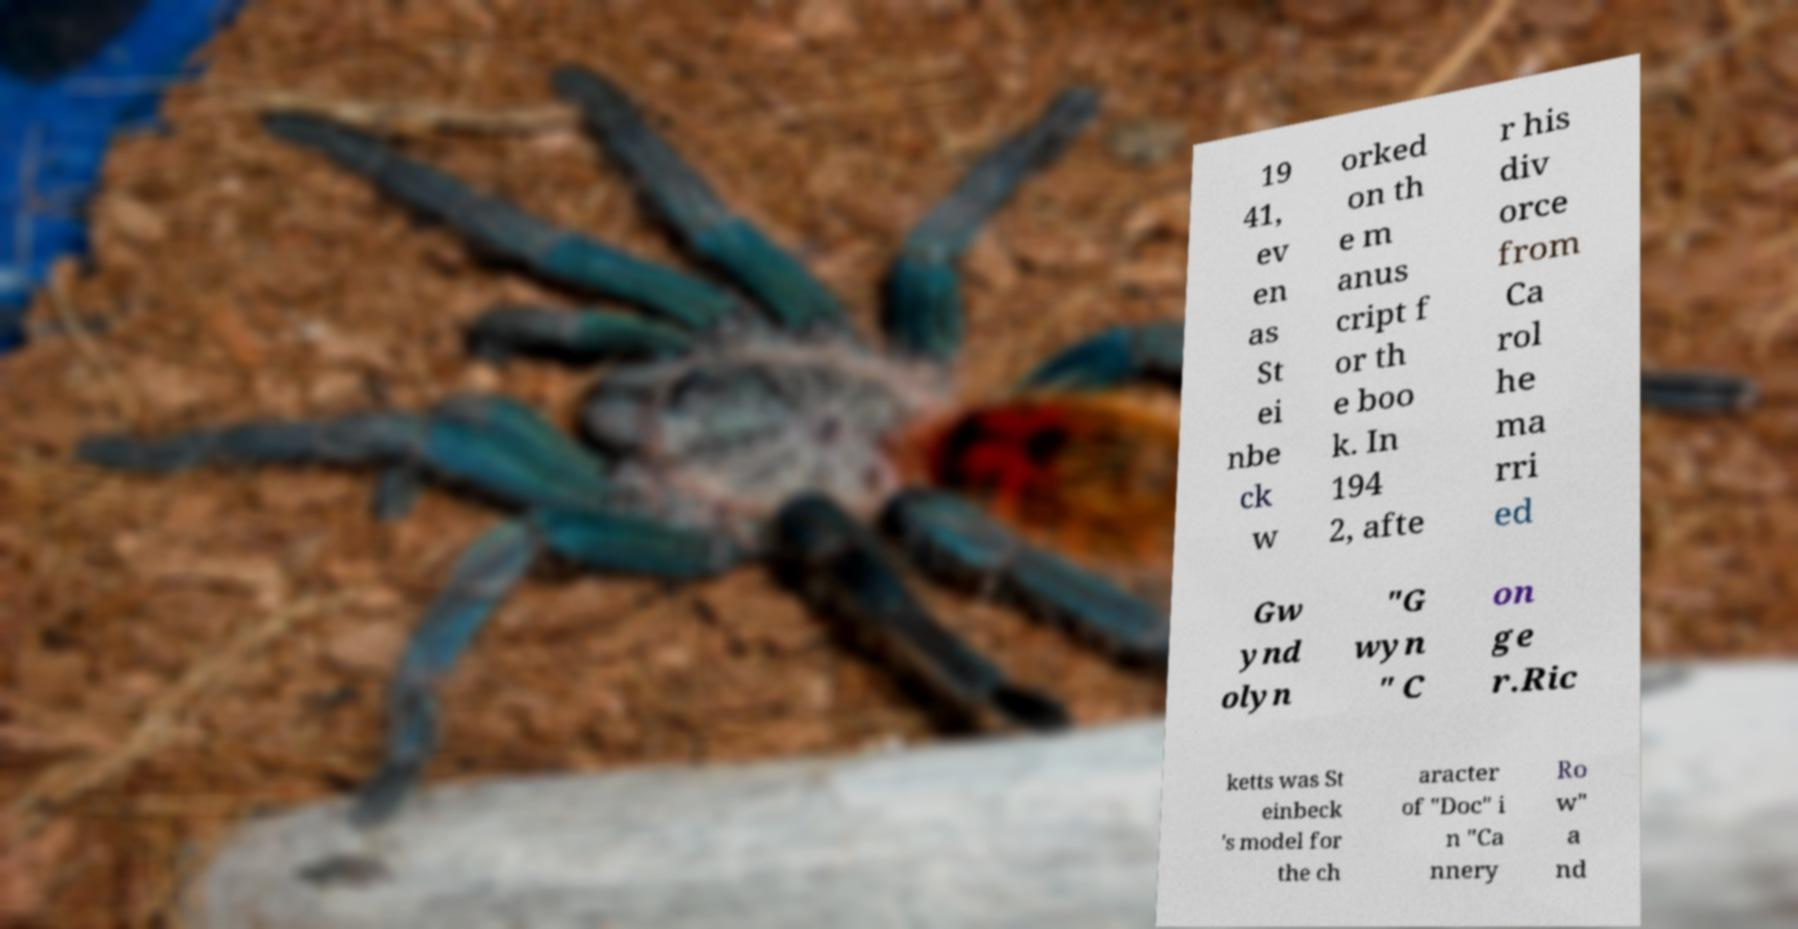Please identify and transcribe the text found in this image. 19 41, ev en as St ei nbe ck w orked on th e m anus cript f or th e boo k. In 194 2, afte r his div orce from Ca rol he ma rri ed Gw ynd olyn "G wyn " C on ge r.Ric ketts was St einbeck 's model for the ch aracter of "Doc" i n "Ca nnery Ro w" a nd 